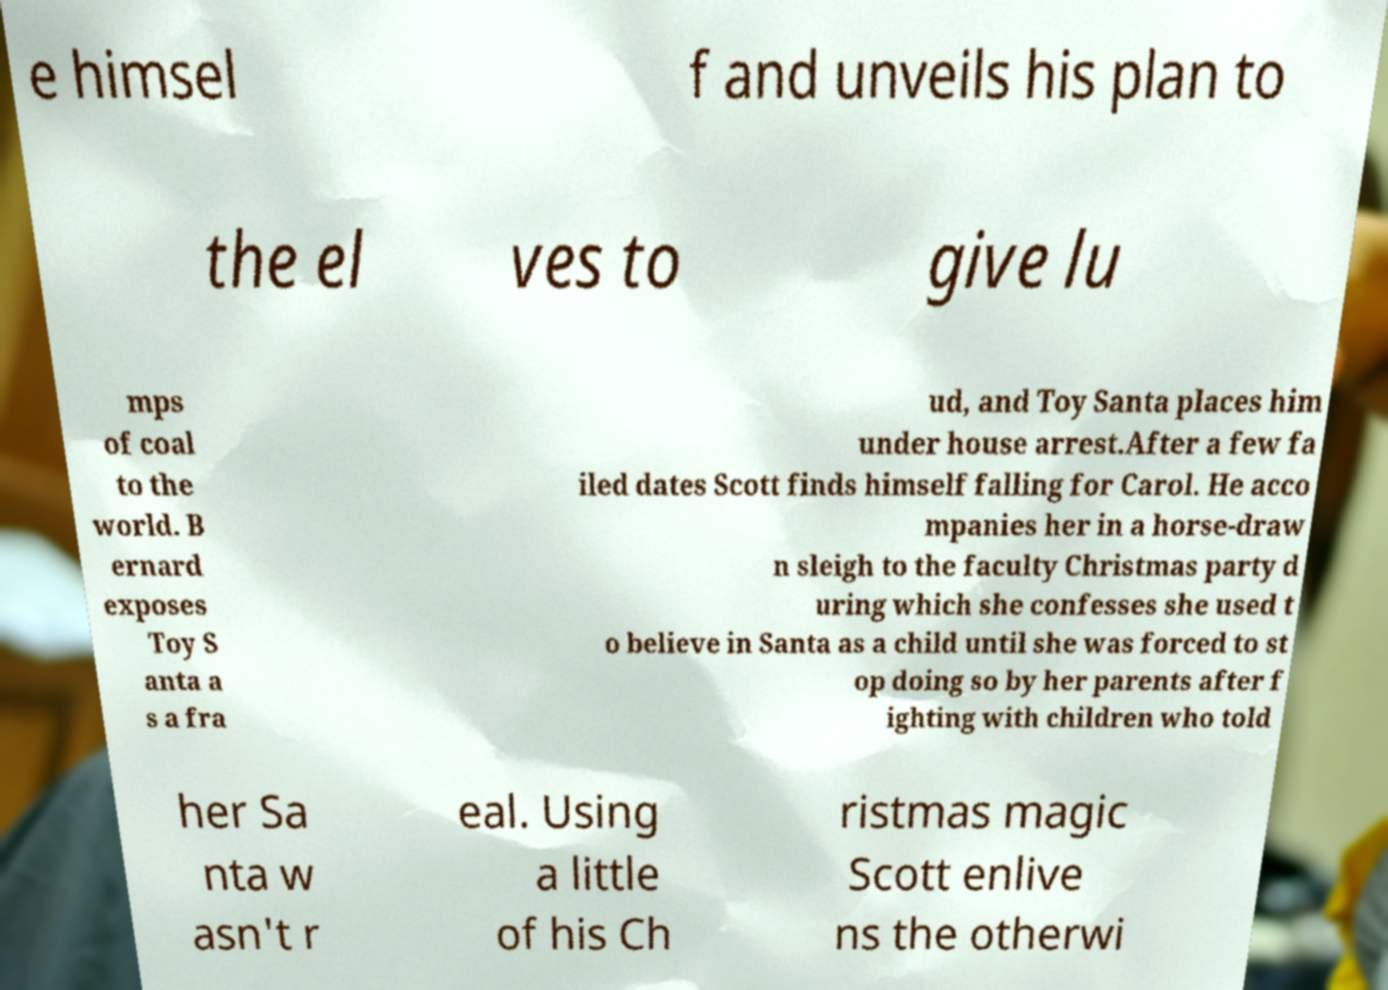Please read and relay the text visible in this image. What does it say? e himsel f and unveils his plan to the el ves to give lu mps of coal to the world. B ernard exposes Toy S anta a s a fra ud, and Toy Santa places him under house arrest.After a few fa iled dates Scott finds himself falling for Carol. He acco mpanies her in a horse-draw n sleigh to the faculty Christmas party d uring which she confesses she used t o believe in Santa as a child until she was forced to st op doing so by her parents after f ighting with children who told her Sa nta w asn't r eal. Using a little of his Ch ristmas magic Scott enlive ns the otherwi 